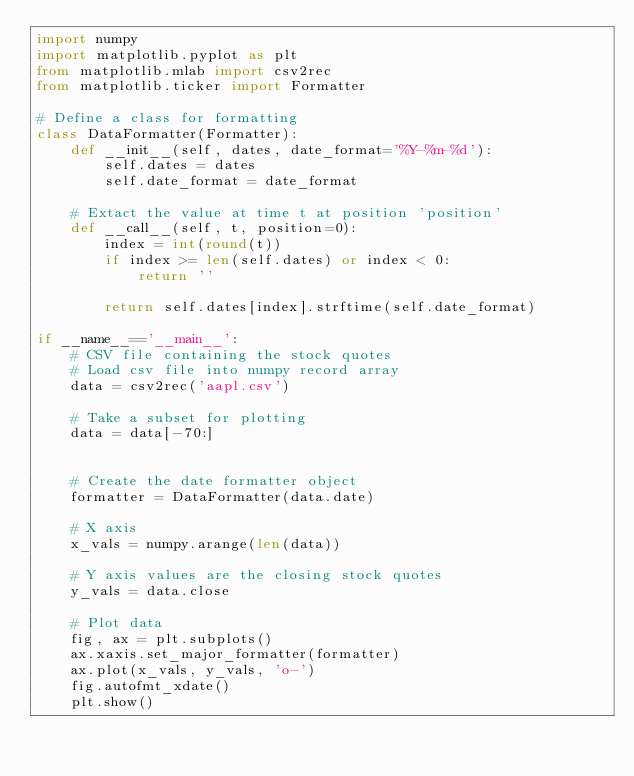<code> <loc_0><loc_0><loc_500><loc_500><_Python_>import numpy
import matplotlib.pyplot as plt
from matplotlib.mlab import csv2rec
from matplotlib.ticker import Formatter

# Define a class for formatting
class DataFormatter(Formatter):
    def __init__(self, dates, date_format='%Y-%m-%d'):
        self.dates = dates
        self.date_format = date_format

    # Extact the value at time t at position 'position'
    def __call__(self, t, position=0):
        index = int(round(t))
        if index >= len(self.dates) or index < 0:
            return ''

        return self.dates[index].strftime(self.date_format)

if __name__=='__main__':
    # CSV file containing the stock quotes 
    # Load csv file into numpy record array
    data = csv2rec('aapl.csv')
    
    # Take a subset for plotting
    data = data[-70:]
    

    # Create the date formatter object
    formatter = DataFormatter(data.date)

    # X axis
    x_vals = numpy.arange(len(data))

    # Y axis values are the closing stock quotes
    y_vals = data.close

    # Plot data
    fig, ax = plt.subplots()
    ax.xaxis.set_major_formatter(formatter)
    ax.plot(x_vals, y_vals, 'o-')
    fig.autofmt_xdate()
    plt.show()
    
    

</code> 